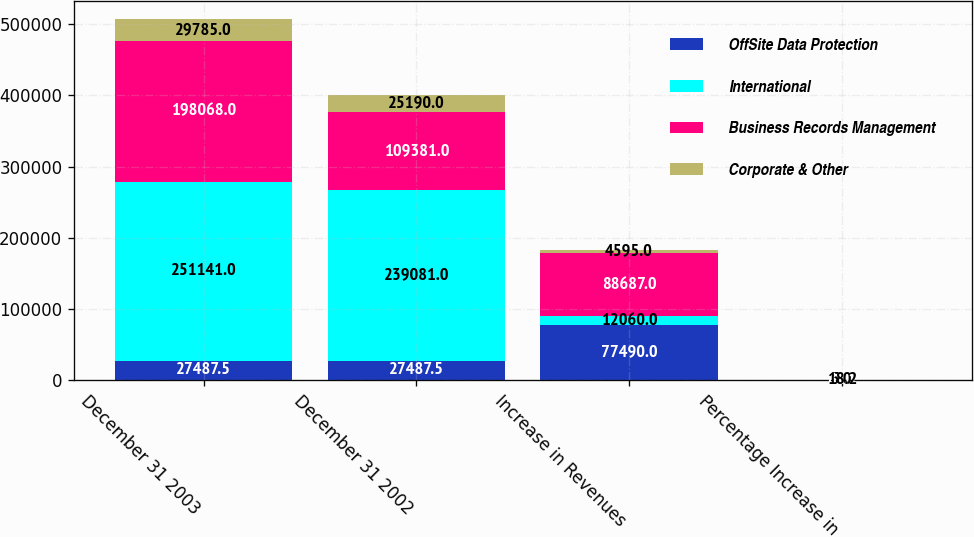Convert chart to OTSL. <chart><loc_0><loc_0><loc_500><loc_500><stacked_bar_chart><ecel><fcel>December 31 2003<fcel>December 31 2002<fcel>Increase in Revenues<fcel>Percentage Increase in<nl><fcel>OffSite Data Protection<fcel>27487.5<fcel>27487.5<fcel>77490<fcel>8.2<nl><fcel>International<fcel>251141<fcel>239081<fcel>12060<fcel>5<nl><fcel>Business Records Management<fcel>198068<fcel>109381<fcel>88687<fcel>81.1<nl><fcel>Corporate & Other<fcel>29785<fcel>25190<fcel>4595<fcel>18.2<nl></chart> 